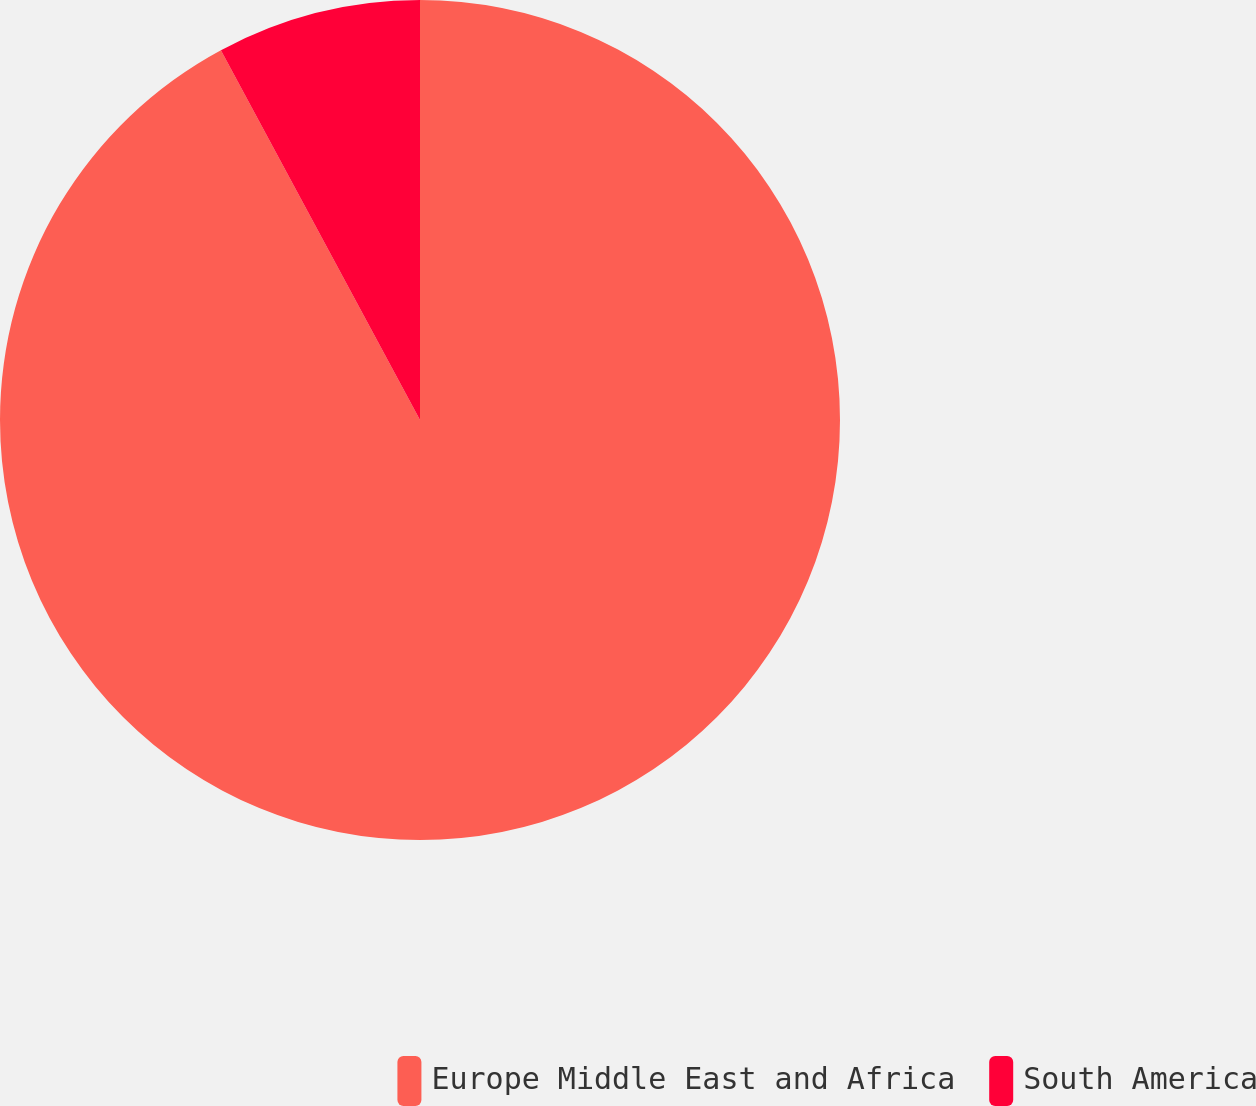<chart> <loc_0><loc_0><loc_500><loc_500><pie_chart><fcel>Europe Middle East and Africa<fcel>South America<nl><fcel>92.14%<fcel>7.86%<nl></chart> 